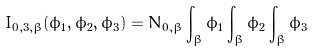Convert formula to latex. <formula><loc_0><loc_0><loc_500><loc_500>I _ { 0 , 3 , \beta } ( \phi _ { 1 } , \phi _ { 2 } , \phi _ { 3 } ) = N _ { 0 , \beta } \int _ { \beta } \phi _ { 1 } \int _ { \beta } \phi _ { 2 } \int _ { \beta } \phi _ { 3 }</formula> 